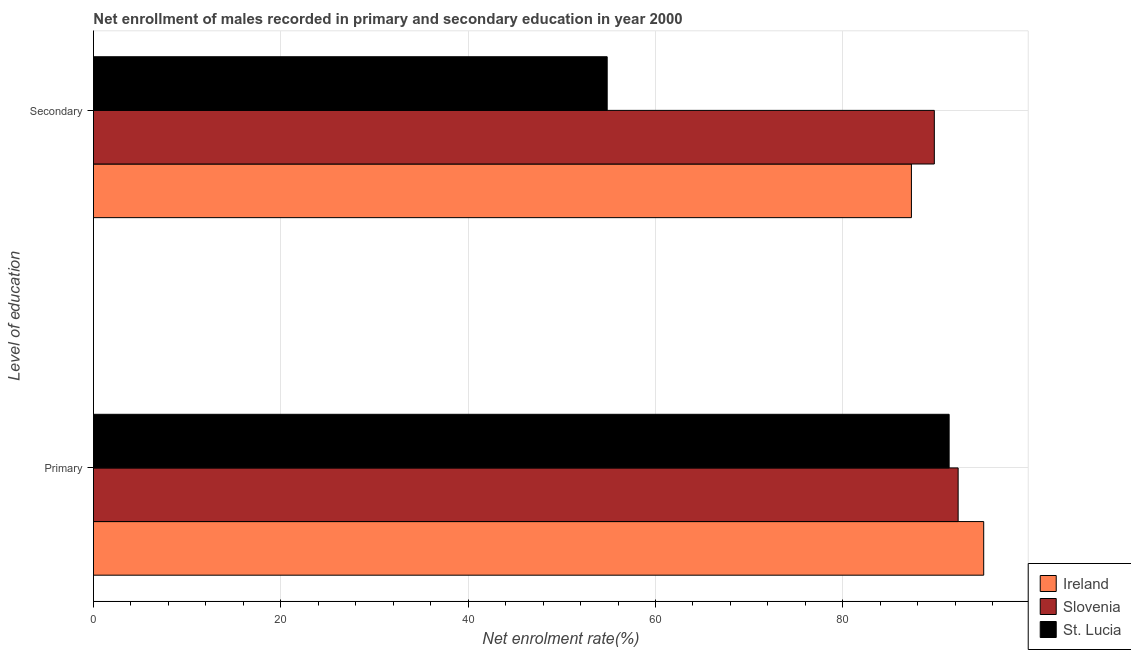Are the number of bars on each tick of the Y-axis equal?
Your answer should be compact. Yes. How many bars are there on the 1st tick from the top?
Keep it short and to the point. 3. How many bars are there on the 2nd tick from the bottom?
Keep it short and to the point. 3. What is the label of the 2nd group of bars from the top?
Offer a very short reply. Primary. What is the enrollment rate in secondary education in St. Lucia?
Provide a short and direct response. 54.85. Across all countries, what is the maximum enrollment rate in primary education?
Your answer should be compact. 95.04. Across all countries, what is the minimum enrollment rate in secondary education?
Provide a short and direct response. 54.85. In which country was the enrollment rate in secondary education maximum?
Your response must be concise. Slovenia. In which country was the enrollment rate in secondary education minimum?
Offer a very short reply. St. Lucia. What is the total enrollment rate in primary education in the graph?
Make the answer very short. 278.71. What is the difference between the enrollment rate in primary education in Ireland and that in St. Lucia?
Provide a short and direct response. 3.69. What is the difference between the enrollment rate in secondary education in St. Lucia and the enrollment rate in primary education in Ireland?
Offer a very short reply. -40.2. What is the average enrollment rate in primary education per country?
Provide a succinct answer. 92.9. What is the difference between the enrollment rate in primary education and enrollment rate in secondary education in Ireland?
Your answer should be very brief. 7.72. In how many countries, is the enrollment rate in secondary education greater than 88 %?
Your answer should be very brief. 1. What is the ratio of the enrollment rate in secondary education in Ireland to that in St. Lucia?
Your answer should be very brief. 1.59. In how many countries, is the enrollment rate in primary education greater than the average enrollment rate in primary education taken over all countries?
Offer a very short reply. 1. What does the 2nd bar from the top in Secondary represents?
Offer a very short reply. Slovenia. What does the 2nd bar from the bottom in Secondary represents?
Offer a terse response. Slovenia. How many countries are there in the graph?
Your answer should be very brief. 3. What is the difference between two consecutive major ticks on the X-axis?
Give a very brief answer. 20. Does the graph contain any zero values?
Your answer should be compact. No. How are the legend labels stacked?
Offer a very short reply. Vertical. What is the title of the graph?
Provide a succinct answer. Net enrollment of males recorded in primary and secondary education in year 2000. Does "Virgin Islands" appear as one of the legend labels in the graph?
Offer a very short reply. No. What is the label or title of the X-axis?
Provide a short and direct response. Net enrolment rate(%). What is the label or title of the Y-axis?
Ensure brevity in your answer.  Level of education. What is the Net enrolment rate(%) of Ireland in Primary?
Provide a short and direct response. 95.04. What is the Net enrolment rate(%) of Slovenia in Primary?
Offer a very short reply. 92.31. What is the Net enrolment rate(%) of St. Lucia in Primary?
Make the answer very short. 91.35. What is the Net enrolment rate(%) of Ireland in Secondary?
Give a very brief answer. 87.33. What is the Net enrolment rate(%) of Slovenia in Secondary?
Provide a succinct answer. 89.77. What is the Net enrolment rate(%) in St. Lucia in Secondary?
Give a very brief answer. 54.85. Across all Level of education, what is the maximum Net enrolment rate(%) in Ireland?
Your answer should be compact. 95.04. Across all Level of education, what is the maximum Net enrolment rate(%) of Slovenia?
Offer a very short reply. 92.31. Across all Level of education, what is the maximum Net enrolment rate(%) in St. Lucia?
Ensure brevity in your answer.  91.35. Across all Level of education, what is the minimum Net enrolment rate(%) in Ireland?
Keep it short and to the point. 87.33. Across all Level of education, what is the minimum Net enrolment rate(%) in Slovenia?
Offer a terse response. 89.77. Across all Level of education, what is the minimum Net enrolment rate(%) in St. Lucia?
Your answer should be very brief. 54.85. What is the total Net enrolment rate(%) in Ireland in the graph?
Provide a short and direct response. 182.37. What is the total Net enrolment rate(%) of Slovenia in the graph?
Offer a very short reply. 182.08. What is the total Net enrolment rate(%) of St. Lucia in the graph?
Provide a succinct answer. 146.2. What is the difference between the Net enrolment rate(%) in Ireland in Primary and that in Secondary?
Your answer should be compact. 7.72. What is the difference between the Net enrolment rate(%) in Slovenia in Primary and that in Secondary?
Your answer should be compact. 2.54. What is the difference between the Net enrolment rate(%) in St. Lucia in Primary and that in Secondary?
Provide a succinct answer. 36.51. What is the difference between the Net enrolment rate(%) in Ireland in Primary and the Net enrolment rate(%) in Slovenia in Secondary?
Offer a very short reply. 5.27. What is the difference between the Net enrolment rate(%) of Ireland in Primary and the Net enrolment rate(%) of St. Lucia in Secondary?
Your answer should be very brief. 40.2. What is the difference between the Net enrolment rate(%) of Slovenia in Primary and the Net enrolment rate(%) of St. Lucia in Secondary?
Ensure brevity in your answer.  37.47. What is the average Net enrolment rate(%) in Ireland per Level of education?
Provide a short and direct response. 91.18. What is the average Net enrolment rate(%) of Slovenia per Level of education?
Ensure brevity in your answer.  91.04. What is the average Net enrolment rate(%) in St. Lucia per Level of education?
Give a very brief answer. 73.1. What is the difference between the Net enrolment rate(%) in Ireland and Net enrolment rate(%) in Slovenia in Primary?
Offer a terse response. 2.73. What is the difference between the Net enrolment rate(%) in Ireland and Net enrolment rate(%) in St. Lucia in Primary?
Keep it short and to the point. 3.69. What is the difference between the Net enrolment rate(%) in Slovenia and Net enrolment rate(%) in St. Lucia in Primary?
Provide a short and direct response. 0.96. What is the difference between the Net enrolment rate(%) in Ireland and Net enrolment rate(%) in Slovenia in Secondary?
Your answer should be very brief. -2.44. What is the difference between the Net enrolment rate(%) of Ireland and Net enrolment rate(%) of St. Lucia in Secondary?
Offer a terse response. 32.48. What is the difference between the Net enrolment rate(%) in Slovenia and Net enrolment rate(%) in St. Lucia in Secondary?
Ensure brevity in your answer.  34.93. What is the ratio of the Net enrolment rate(%) of Ireland in Primary to that in Secondary?
Your response must be concise. 1.09. What is the ratio of the Net enrolment rate(%) of Slovenia in Primary to that in Secondary?
Make the answer very short. 1.03. What is the ratio of the Net enrolment rate(%) of St. Lucia in Primary to that in Secondary?
Provide a short and direct response. 1.67. What is the difference between the highest and the second highest Net enrolment rate(%) of Ireland?
Provide a short and direct response. 7.72. What is the difference between the highest and the second highest Net enrolment rate(%) in Slovenia?
Offer a very short reply. 2.54. What is the difference between the highest and the second highest Net enrolment rate(%) in St. Lucia?
Your answer should be compact. 36.51. What is the difference between the highest and the lowest Net enrolment rate(%) in Ireland?
Ensure brevity in your answer.  7.72. What is the difference between the highest and the lowest Net enrolment rate(%) in Slovenia?
Offer a very short reply. 2.54. What is the difference between the highest and the lowest Net enrolment rate(%) of St. Lucia?
Keep it short and to the point. 36.51. 